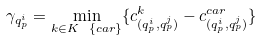<formula> <loc_0><loc_0><loc_500><loc_500>\gamma _ { q ^ { i } _ { p } } = \min _ { k \in K \ \{ c a r \} } \{ c ^ { k } _ { ( q ^ { i } _ { p } , q ^ { j } _ { p } ) } - c ^ { c a r } _ { ( q ^ { i } _ { p } , q ^ { j } _ { p } ) } \}</formula> 